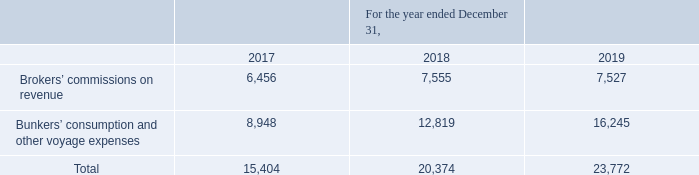GasLog Ltd. and its Subsidiaries
Notes to the consolidated financial statements (Continued)
For the years ended December 31, 2017, 2018 and 2019
(All amounts expressed in thousands of U.S. Dollars, except share and per share data)
16. Voyage Expenses and Commissions
An analysis of voyage expenses and commissions is as follows:
Bunkers’ consumption and other voyage expenses represents mainly bunkers consumed during vessels’ unemployment and off-hire.
What does bunkers’ consumption and other voyage expenses represent? Bunkers’ consumption and other voyage expenses represents mainly bunkers consumed during vessels’ unemployment and off-hire. In which year was the voyage expenses and commissions recorded for? 2017, 2018, 2019. What was the brokers' commissions on revenue in 2017?
Answer scale should be: thousand. 6,456. In which year was the brokers' commissions on revenue the highest? 7,555 > 7,527 > 6,456
Answer: 2018. What was the change in bunkers’ consumption and other voyage expenses from 2018 to 2019?
Answer scale should be: thousand. 16,245 - 12,819 
Answer: 3426. What was the percentage change in total voyage expenses and commissions from 2017 to 2018?
Answer scale should be: percent. (20,374 - 15,404)/15,404 
Answer: 32.26. 